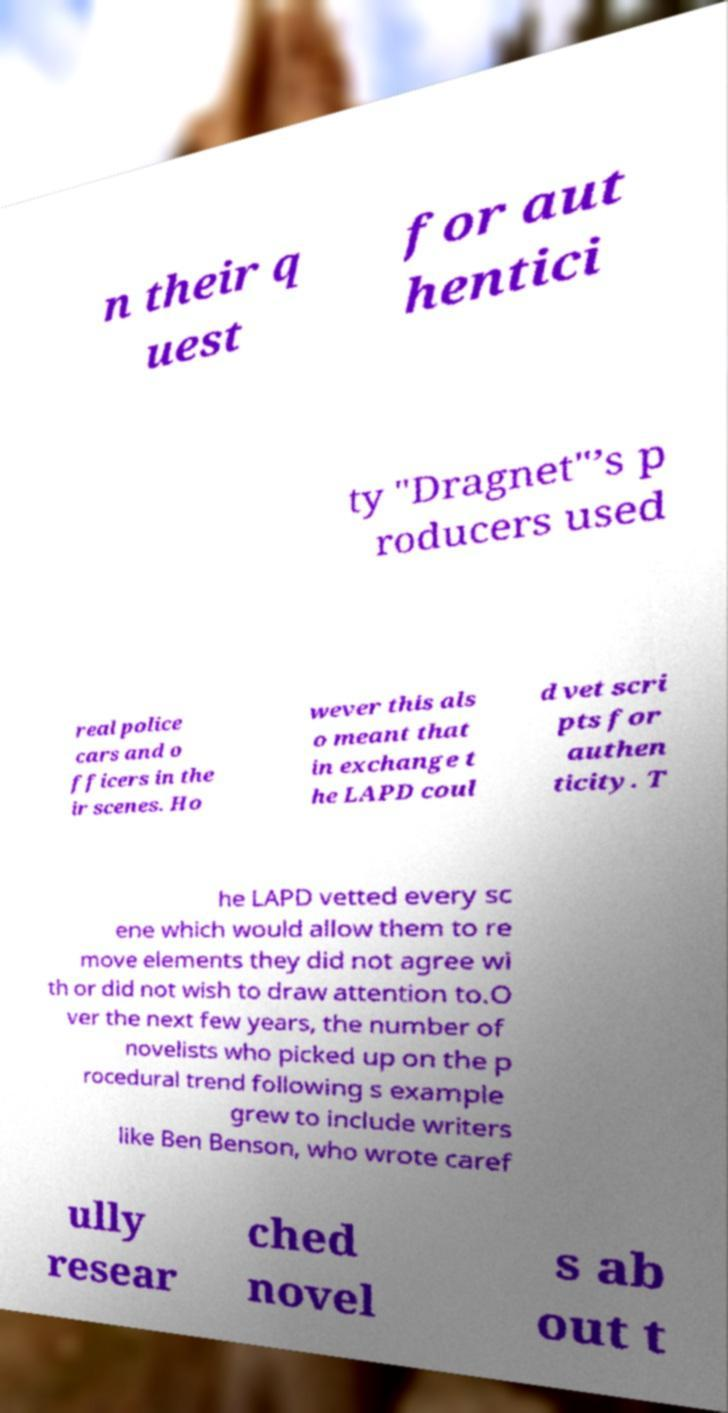Can you accurately transcribe the text from the provided image for me? n their q uest for aut hentici ty "Dragnet"’s p roducers used real police cars and o fficers in the ir scenes. Ho wever this als o meant that in exchange t he LAPD coul d vet scri pts for authen ticity. T he LAPD vetted every sc ene which would allow them to re move elements they did not agree wi th or did not wish to draw attention to.O ver the next few years, the number of novelists who picked up on the p rocedural trend following s example grew to include writers like Ben Benson, who wrote caref ully resear ched novel s ab out t 